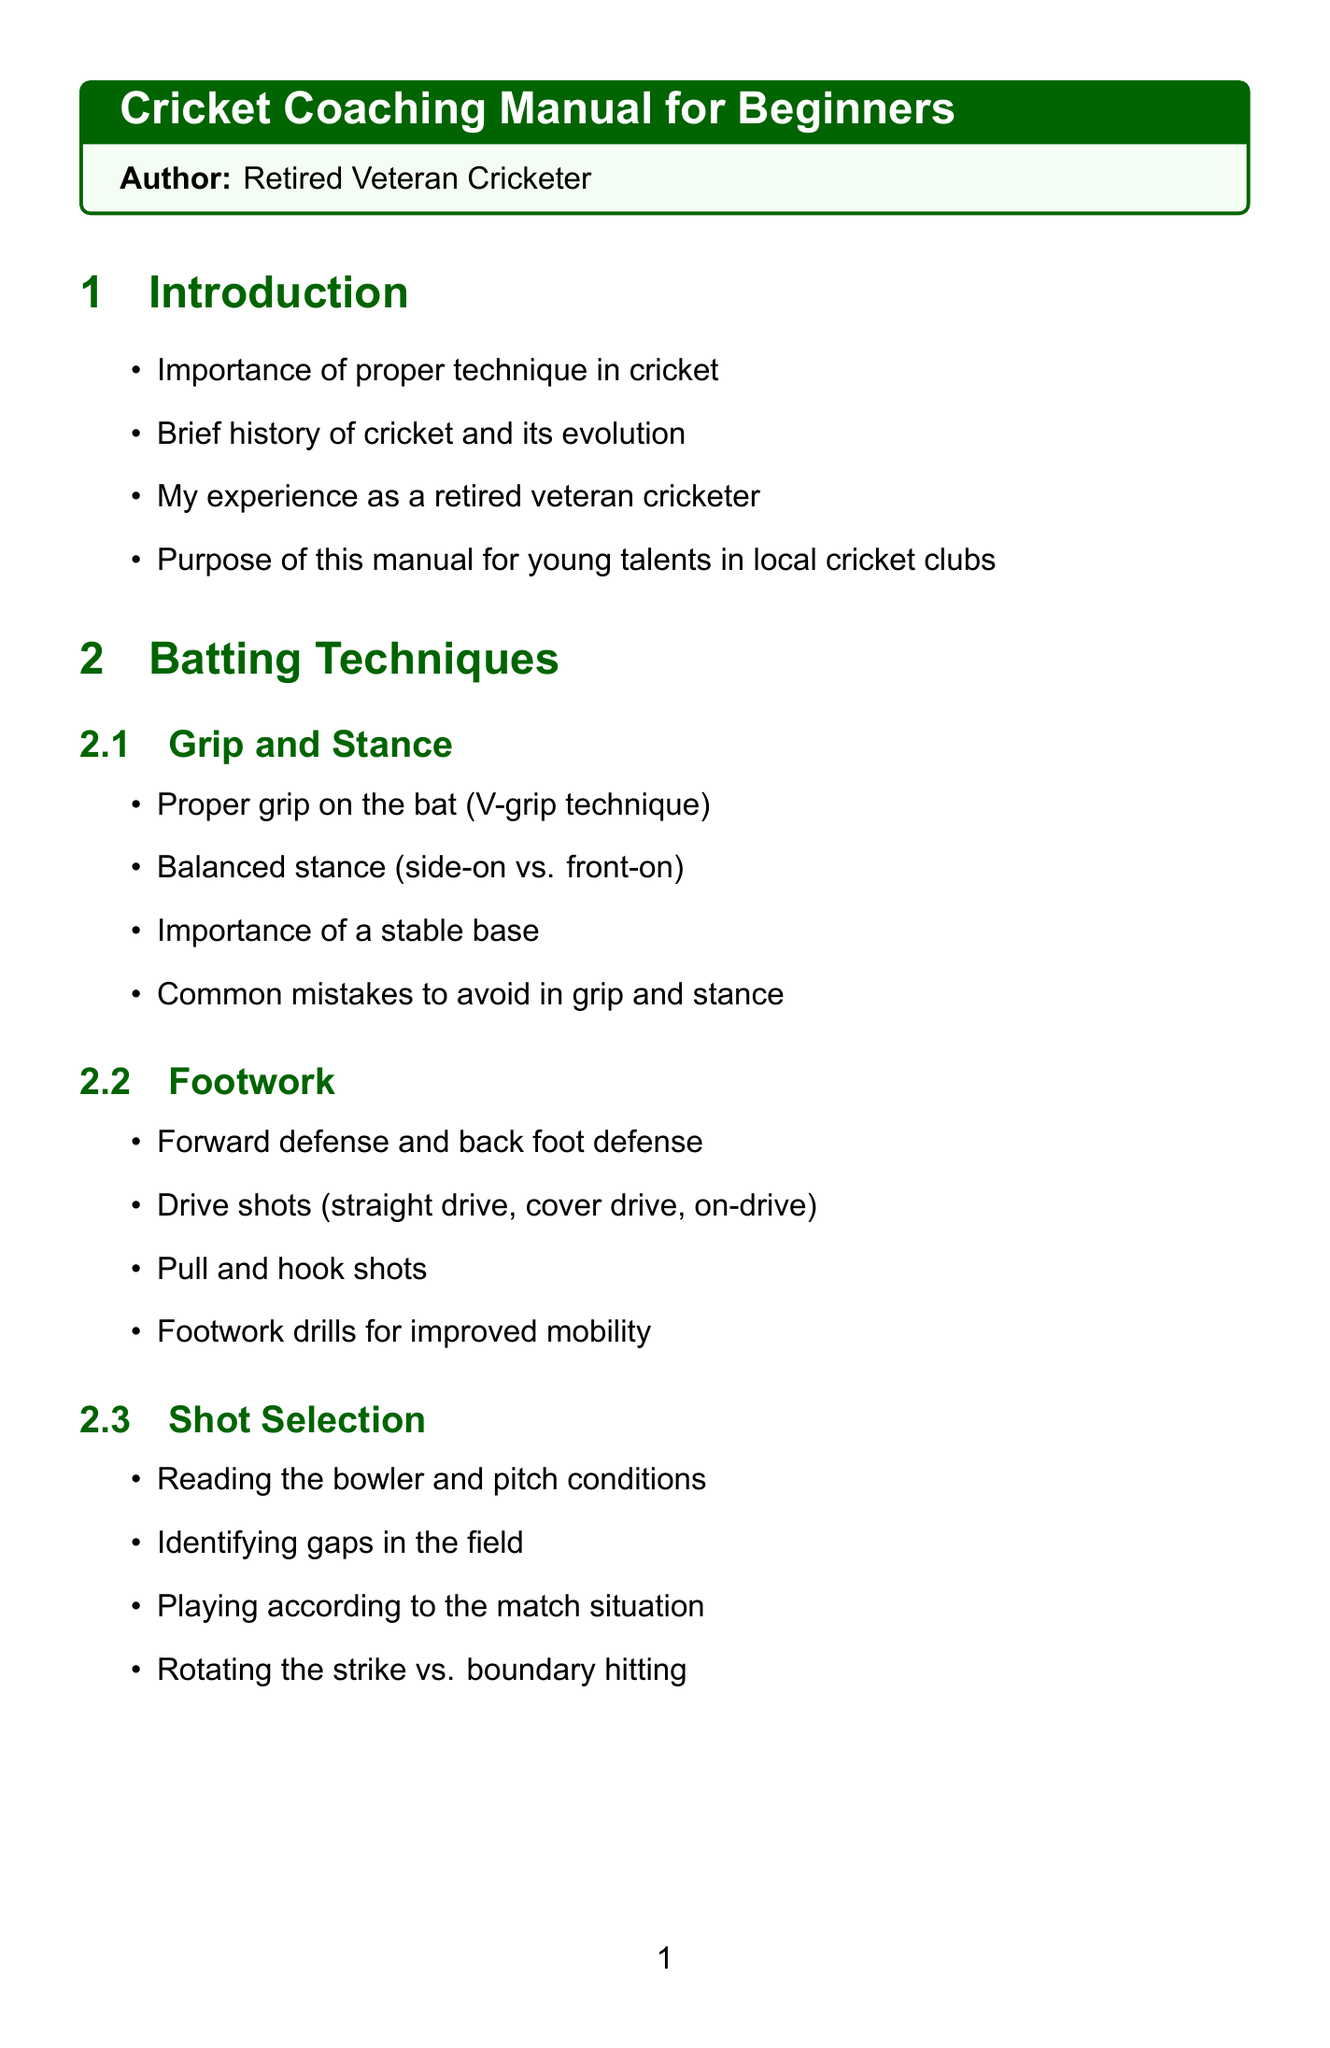What is the title of the manual? The title is explicitly mentioned at the beginning of the document.
Answer: Cricket Coaching Manual for Beginners Who is the author of the manual? The author's name is provided in the title section of the document.
Answer: Retired Veteran Cricketer What technique is emphasized for grip on the bat? The manual specifies a particular grip technique in the batting section.
Answer: V-grip technique What are the types of spin mentioned in spin bowling? The document lists different types of spin in the related subsection.
Answer: Off-spin, leg-spin, and googly What is the purpose of this manual? The purpose is outlined in the introduction section of the document.
Answer: For young talents in local cricket clubs What should be avoided in grip and stance? Common mistakes in grip and stance are highlighted in the batting section.
Answer: Common mistakes What should a bowler adapt to when bowling? The bowling strategies section mentions specific considerations for bowlers.
Answer: Different formats What are the components of the training regimen? The training regimen section outlines key activities for players.
Answer: Warm-up routines, fitness drills, net practice, recovery What mindset is important for players? The mental preparation section discusses the type of mindset players should develop.
Answer: Winning mindset What is the importance of continuous learning? The conclusion emphasizes a specific aspect of player development.
Answer: Continuous learning and practice 